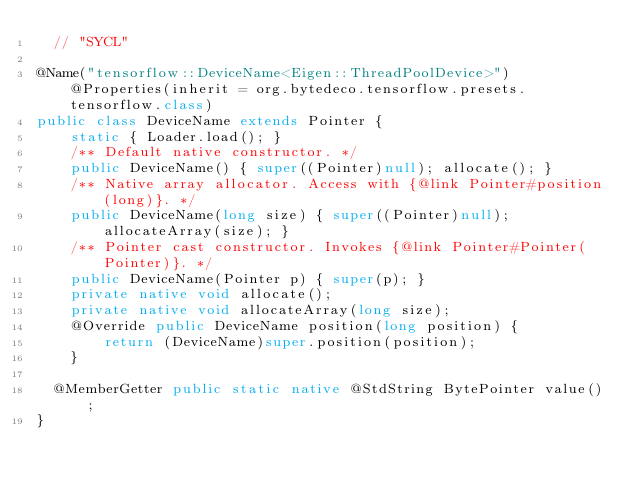<code> <loc_0><loc_0><loc_500><loc_500><_Java_>  // "SYCL"

@Name("tensorflow::DeviceName<Eigen::ThreadPoolDevice>") @Properties(inherit = org.bytedeco.tensorflow.presets.tensorflow.class)
public class DeviceName extends Pointer {
    static { Loader.load(); }
    /** Default native constructor. */
    public DeviceName() { super((Pointer)null); allocate(); }
    /** Native array allocator. Access with {@link Pointer#position(long)}. */
    public DeviceName(long size) { super((Pointer)null); allocateArray(size); }
    /** Pointer cast constructor. Invokes {@link Pointer#Pointer(Pointer)}. */
    public DeviceName(Pointer p) { super(p); }
    private native void allocate();
    private native void allocateArray(long size);
    @Override public DeviceName position(long position) {
        return (DeviceName)super.position(position);
    }

  @MemberGetter public static native @StdString BytePointer value();
}
</code> 